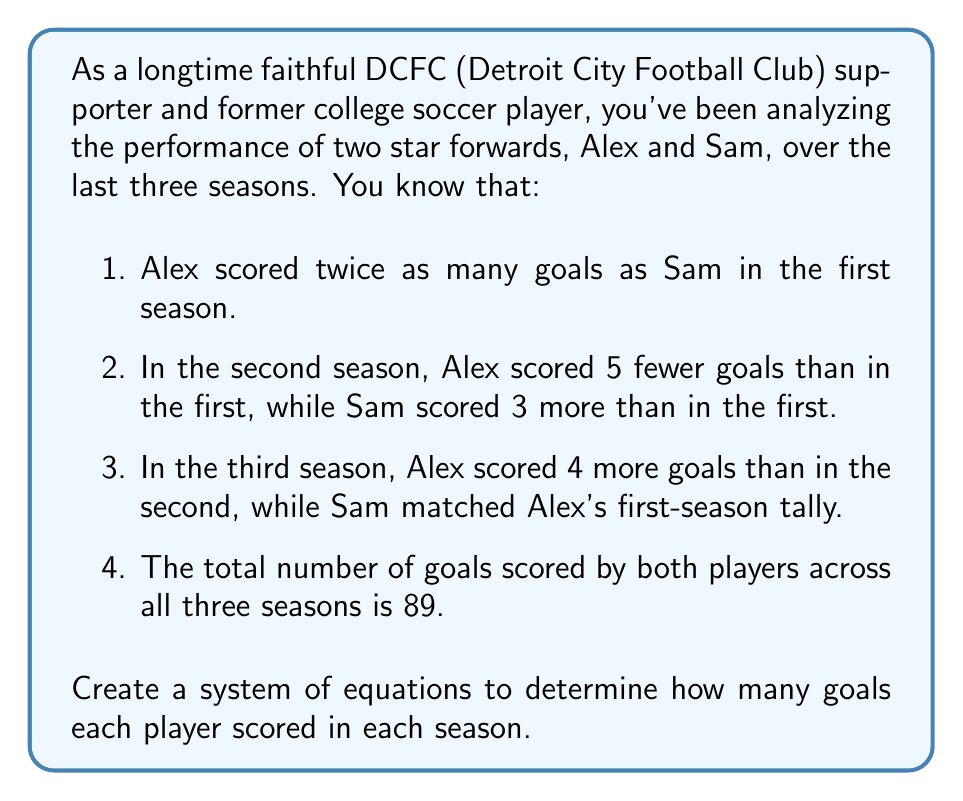Show me your answer to this math problem. Let's approach this step-by-step:

1) Let's define our variables:
   $x$ = number of goals Sam scored in the first season
   $y$ = number of goals Alex scored in the first season

2) Now, let's create equations based on the given information:

   First season:
   $y = 2x$ (Alex scored twice as many as Sam)

   Second season:
   Alex: $y - 5$
   Sam: $x + 3$

   Third season:
   Alex: $(y - 5) + 4 = y - 1$
   Sam: $y$ (Sam matched Alex's first-season tally)

3) Now, let's sum up all goals for both players across three seasons:
   $$(x) + (x + 3) + (y) + (y) + (y - 5) + (y - 1) = 89$$

4) Simplify:
   $$2x + 3y - 6 = 89$$

5) Substitute $y = 2x$ from the first equation:
   $$2x + 3(2x) - 6 = 89$$
   $$2x + 6x - 6 = 89$$
   $$8x - 6 = 89$$
   $$8x = 95$$
   $$x = \frac{95}{8} = 11.875$$

6) Since we're dealing with whole numbers of goals, we round to the nearest integer:
   $x = 12$ (Sam's goals in the first season)

7) Now we can calculate the rest:
   $y = 2x = 2(12) = 24$ (Alex's goals in the first season)

   Second season:
   Sam: $12 + 3 = 15$
   Alex: $24 - 5 = 19$

   Third season:
   Sam: $24$
   Alex: $19 + 4 = 23$

8) Verify: $12 + 15 + 24 + 24 + 19 + 23 = 117$ (total for both players over three seasons)
Answer: Sam's goals: 12 (Season 1), 15 (Season 2), 24 (Season 3)
Alex's goals: 24 (Season 1), 19 (Season 2), 23 (Season 3) 